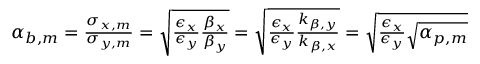Convert formula to latex. <formula><loc_0><loc_0><loc_500><loc_500>\begin{array} { r } { \alpha _ { b , m } = \frac { \sigma _ { x , m } } { \sigma _ { y , m } } = \sqrt { \frac { \epsilon _ { x } } { \epsilon _ { y } } \frac { \beta _ { x } } { \beta _ { y } } } = \sqrt { \frac { \epsilon _ { x } } { \epsilon _ { y } } \frac { k _ { \beta , y } } { k _ { \beta , x } } } = \sqrt { \frac { \epsilon _ { x } } { \epsilon _ { y } } \sqrt { \alpha _ { p , m } } } } \end{array}</formula> 